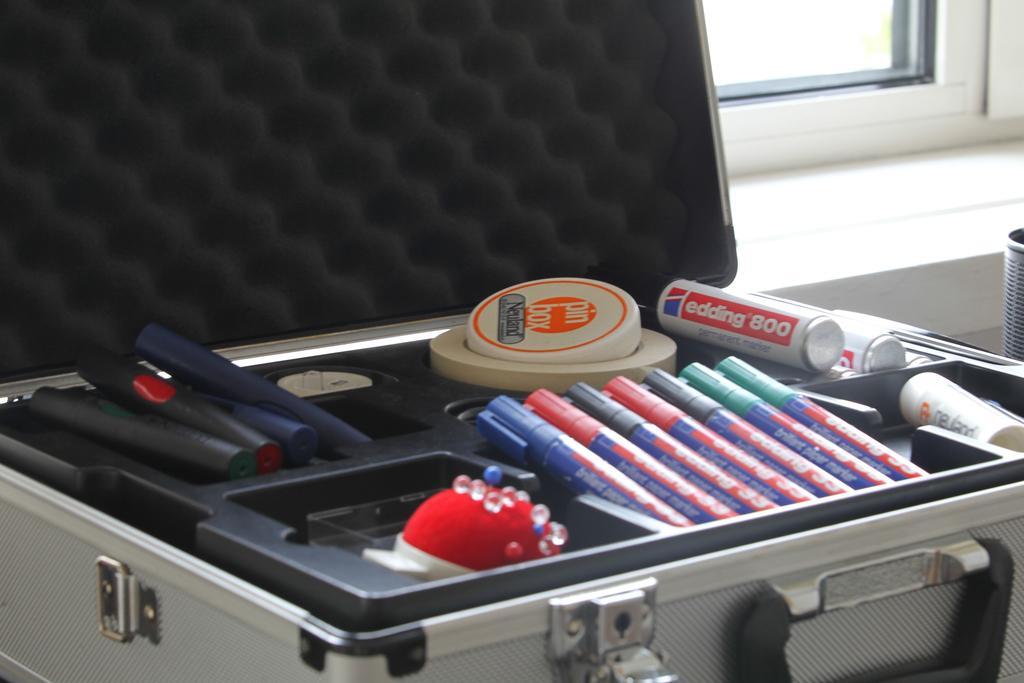Can you describe this image briefly? In this Image I see a suitcase, in which there are pens and other few things. In the background I see the window. 